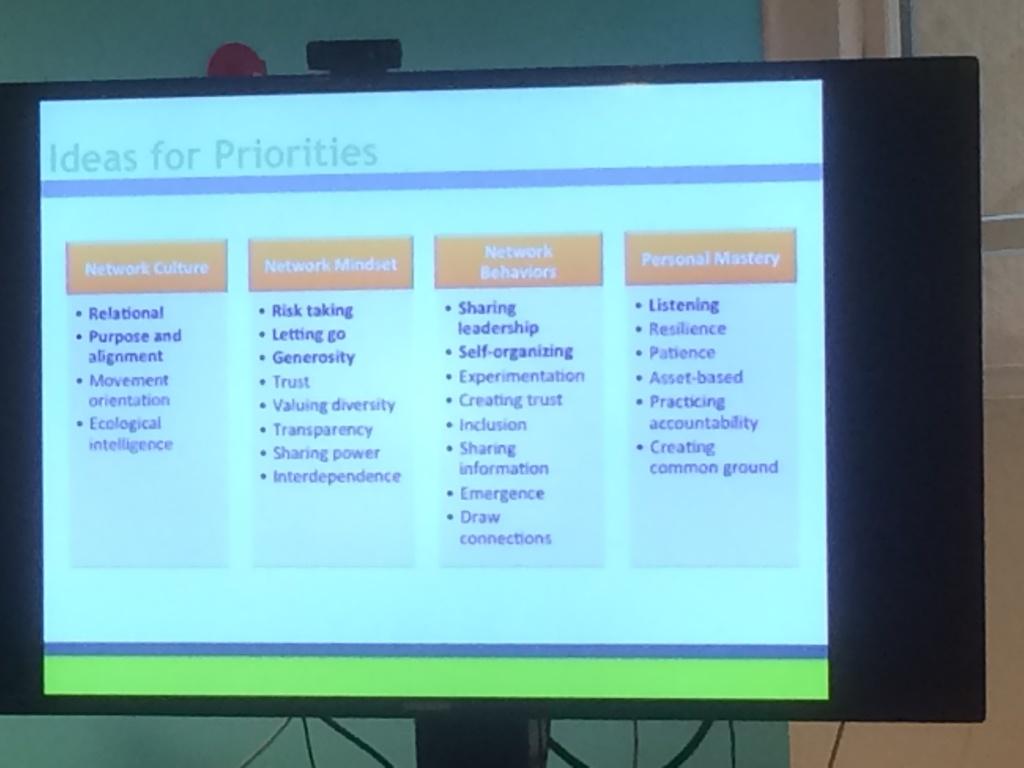What does the right-most orange box say?
Provide a succinct answer. Personal mastery. What are the ideas for>?
Offer a terse response. Priorities. 